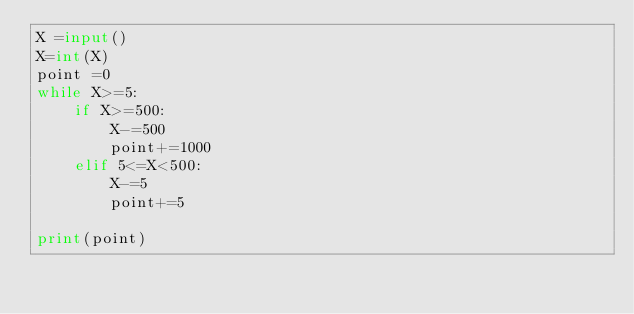Convert code to text. <code><loc_0><loc_0><loc_500><loc_500><_Python_>X =input()
X=int(X)
point =0
while X>=5:
    if X>=500:
        X-=500
        point+=1000
    elif 5<=X<500:
        X-=5
        point+=5

print(point)</code> 